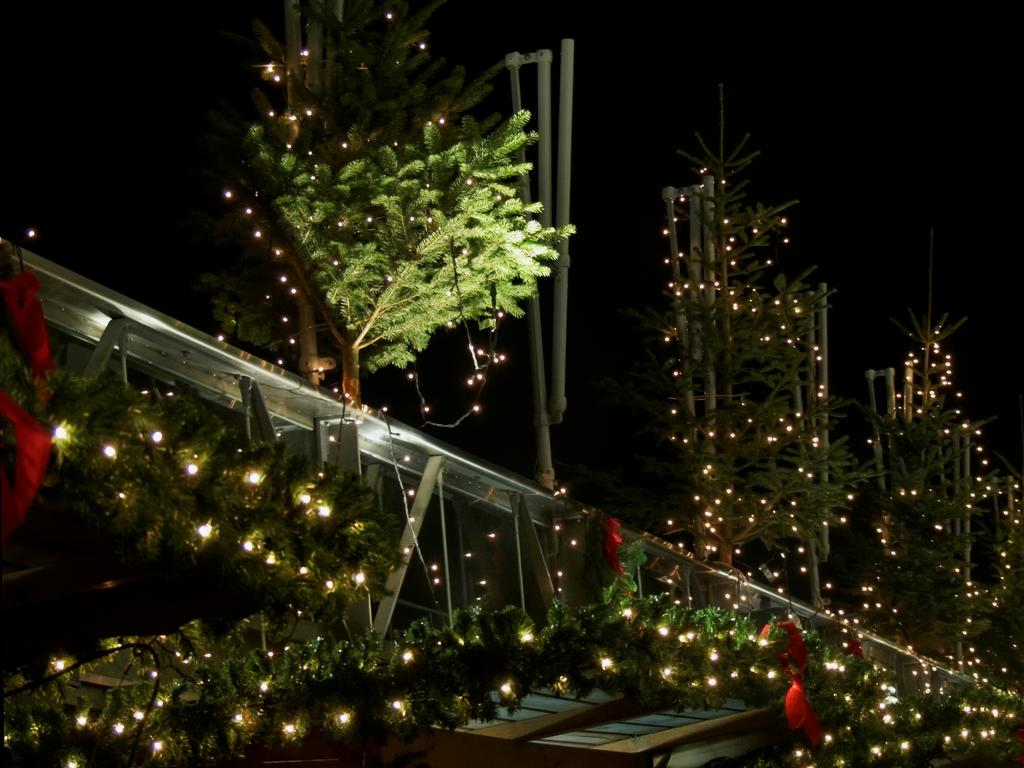What type of structure can be seen in the image? There is fencing in the image. Are there any light sources visible in the image? Yes, there are lights in the image. What type of natural elements are present in the image? There are plants in the image. What material is the wooden object made of? The wooden object is made of wood. What color is the cloth on the left side of the image? The cloth on the left side of the image is red. How many visitors are present in the image? There is no indication of any visitors in the image. What type of country is depicted in the image? The image does not depict a country; it contains fencing, lights, plants, a wooden object, and a red cloth. 